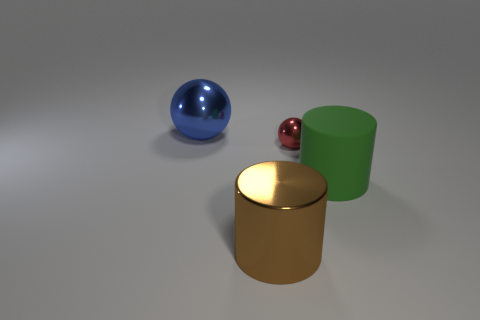Add 4 metal things. How many objects exist? 8 Subtract 1 red spheres. How many objects are left? 3 Subtract all big red balls. Subtract all big blue objects. How many objects are left? 3 Add 4 rubber cylinders. How many rubber cylinders are left? 5 Add 3 metallic spheres. How many metallic spheres exist? 5 